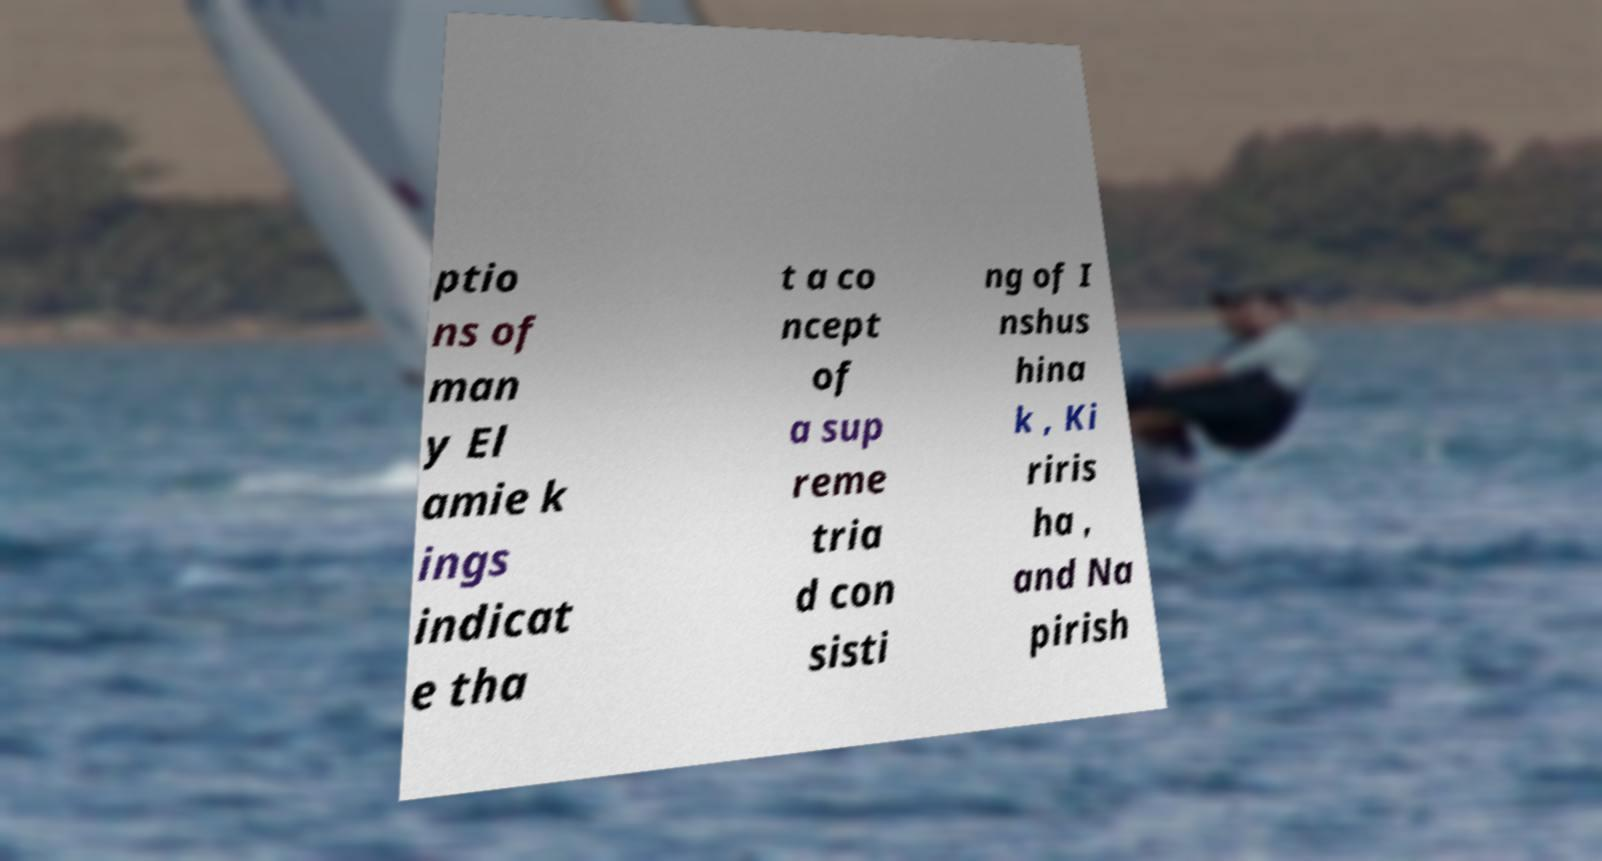I need the written content from this picture converted into text. Can you do that? ptio ns of man y El amie k ings indicat e tha t a co ncept of a sup reme tria d con sisti ng of I nshus hina k , Ki riris ha , and Na pirish 